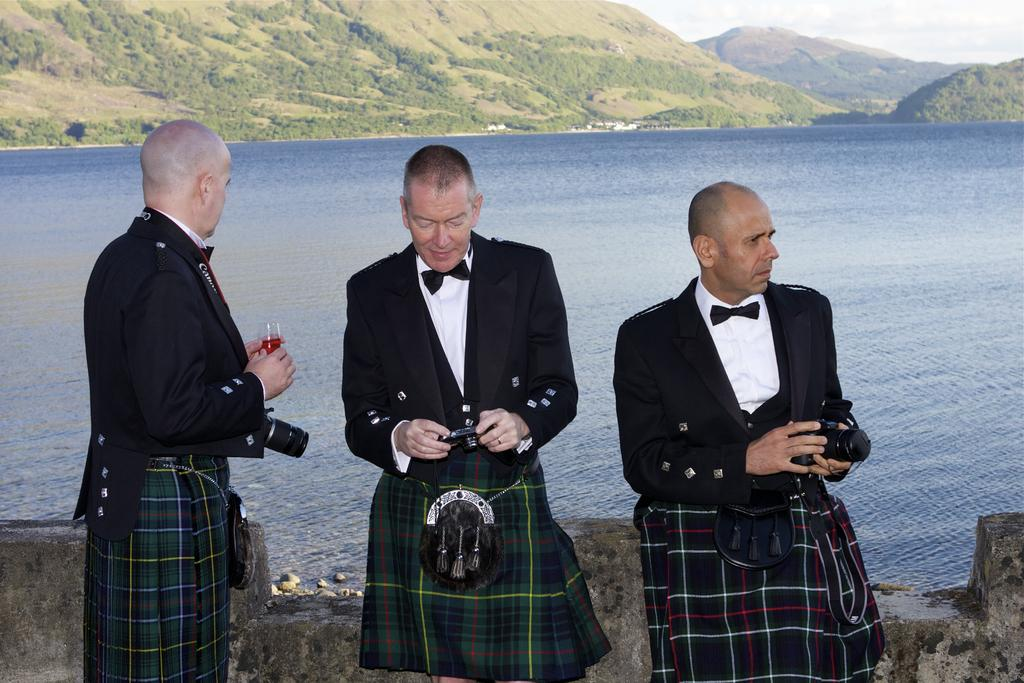How many people are in the image? There are three people standing in the image. What are the people holding in the image? The people are holding objects. What type of natural environment can be seen in the image? There are trees, stones, mountains, water, and sky visible in the image. What is the condition of the sky in the image? The sky is visible in the image, and clouds are present. Where is the store located in the image? There is no store present in the image. What type of cracker is being eaten by the cow in the image? There is no cow or cracker present in the image. 